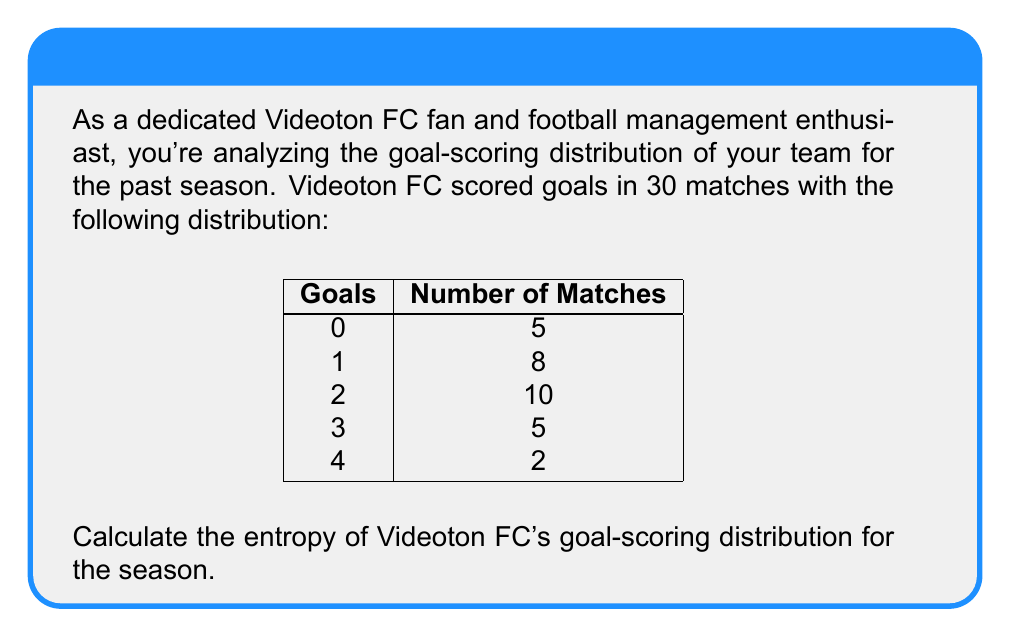What is the answer to this math problem? To calculate the entropy of Videoton FC's goal-scoring distribution, we'll follow these steps:

1) First, let's recall the formula for entropy:
   $$H = -\sum_{i=1}^{n} p_i \log_2(p_i)$$
   where $p_i$ is the probability of each outcome.

2) Calculate the total number of matches:
   $5 + 8 + 10 + 5 + 2 = 30$ matches

3) Calculate the probability for each outcome:
   $p(0) = 5/30 = 1/6$
   $p(1) = 8/30 = 4/15$
   $p(2) = 10/30 = 1/3$
   $p(3) = 5/30 = 1/6$
   $p(4) = 2/30 = 1/15$

4) Now, let's calculate each term of the sum:
   $-(1/6) \log_2(1/6) = 0.4308$
   $-(4/15) \log_2(4/15) = 0.5188$
   $-(1/3) \log_2(1/3) = 0.5283$
   $-(1/6) \log_2(1/6) = 0.4308$
   $-(1/15) \log_2(1/15) = 0.2602$

5) Sum all these terms:
   $H = 0.4308 + 0.5188 + 0.5283 + 0.4308 + 0.2602 = 2.1689$ bits

Therefore, the entropy of Videoton FC's goal-scoring distribution is approximately 2.1689 bits.
Answer: 2.1689 bits 